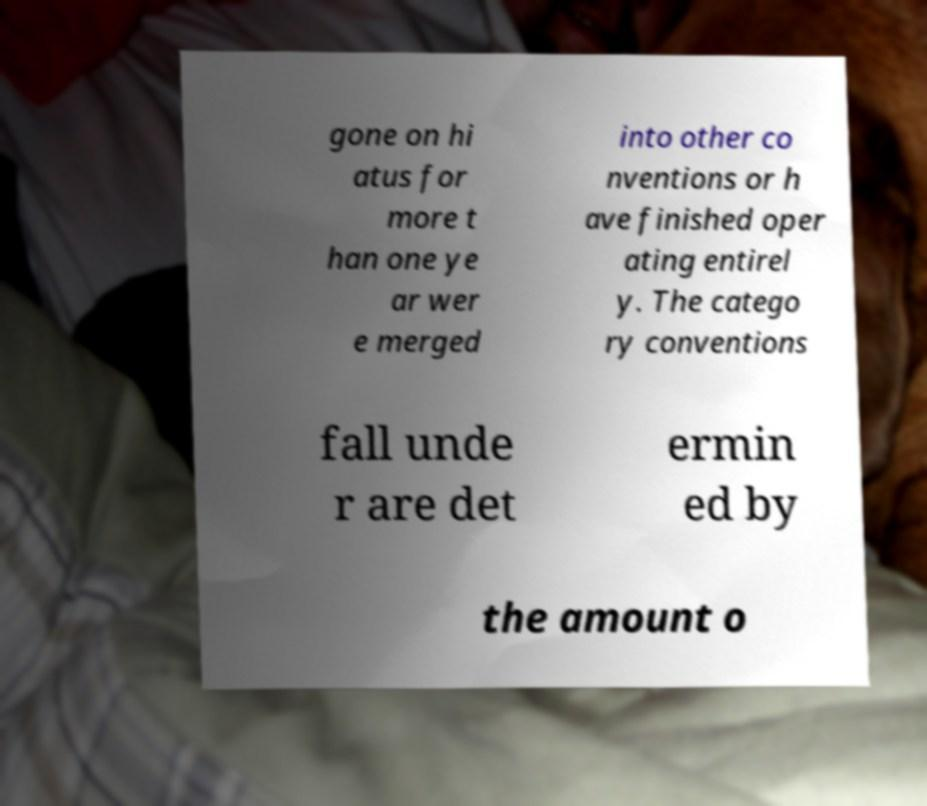I need the written content from this picture converted into text. Can you do that? gone on hi atus for more t han one ye ar wer e merged into other co nventions or h ave finished oper ating entirel y. The catego ry conventions fall unde r are det ermin ed by the amount o 